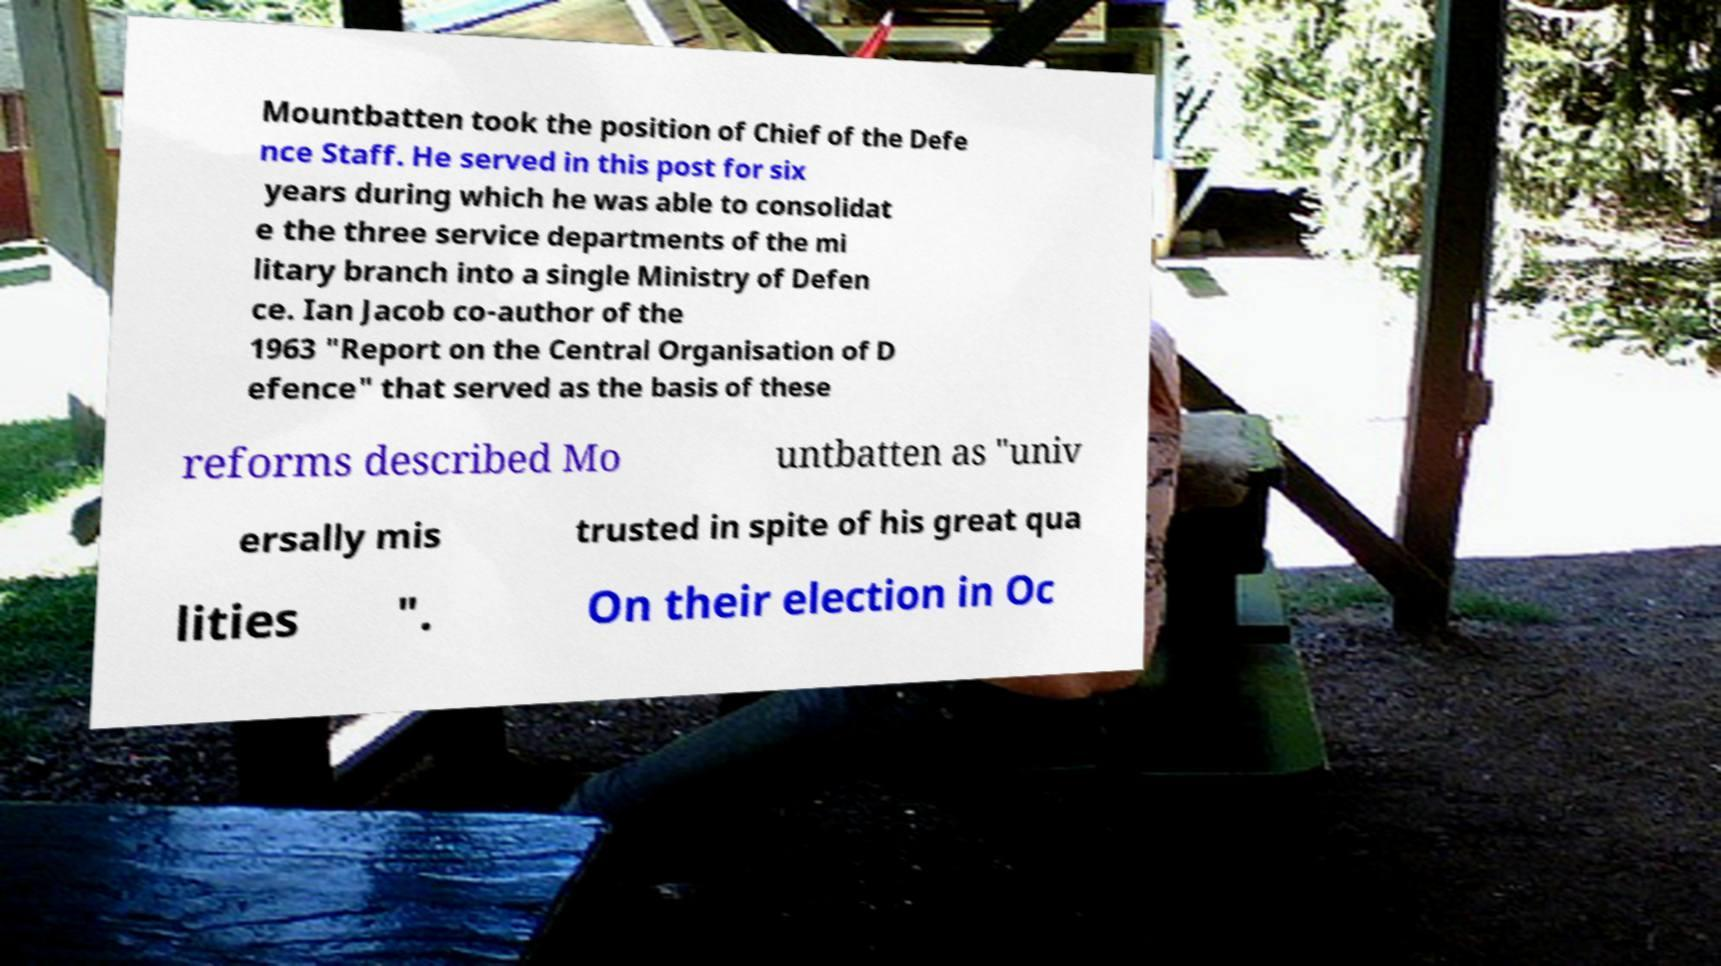Please identify and transcribe the text found in this image. Mountbatten took the position of Chief of the Defe nce Staff. He served in this post for six years during which he was able to consolidat e the three service departments of the mi litary branch into a single Ministry of Defen ce. Ian Jacob co-author of the 1963 "Report on the Central Organisation of D efence" that served as the basis of these reforms described Mo untbatten as "univ ersally mis trusted in spite of his great qua lities ". On their election in Oc 